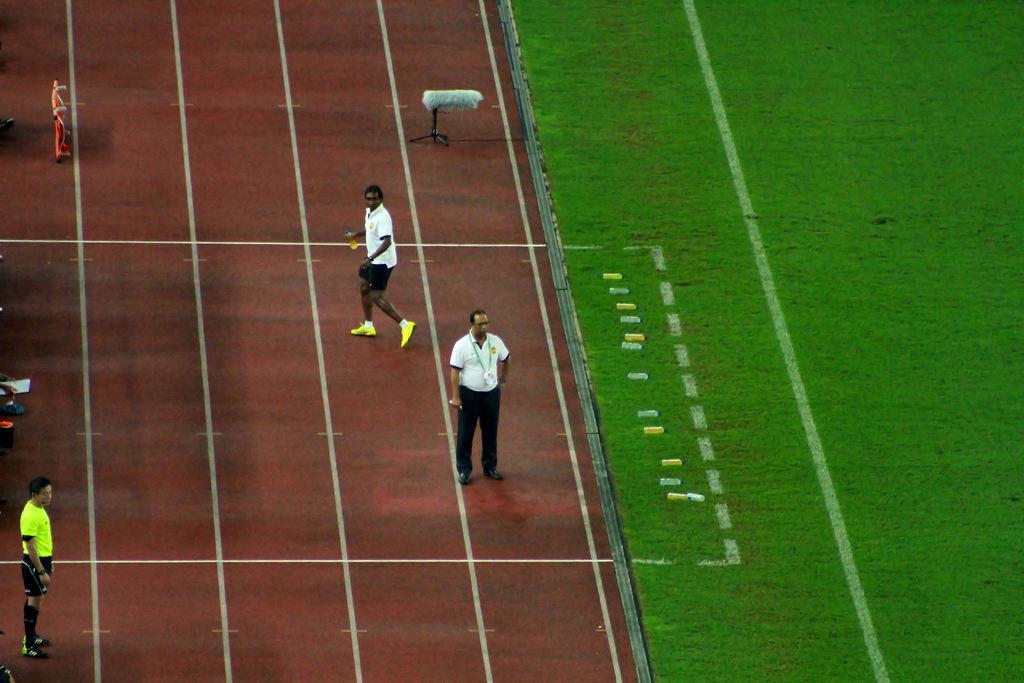Describe this image in one or two sentences. In this picture there are people in the center of the image and there are other people on the left side of the image, it seems to be a playground and there is grass land on the right side of the image. 